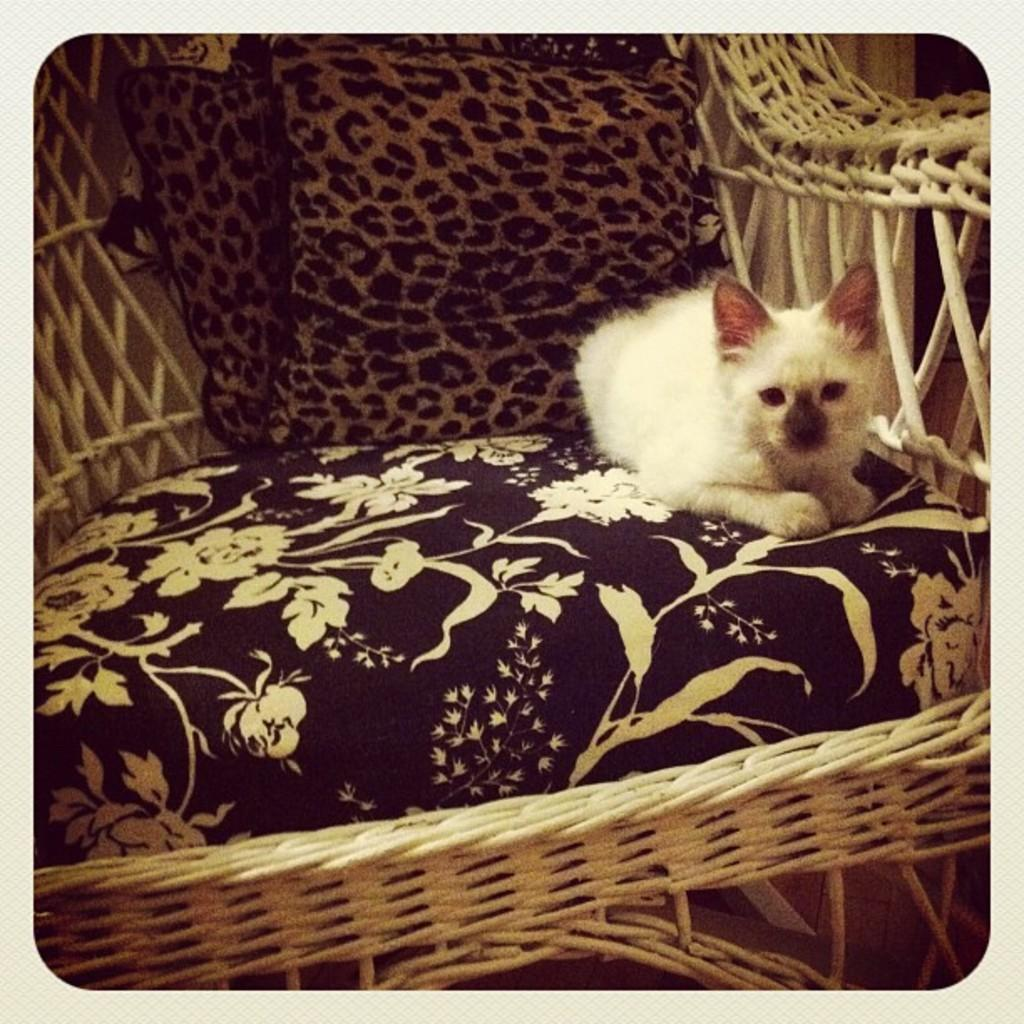What color is the animal in the image? The animal in the image is white-colored. Where is the animal located in the image? The animal is sitting on a sofa chair. What is the animal's theory about the distance between the stars? There is no information about the animal's thoughts or theories in the image, as it only shows the animal sitting on a sofa chair. 